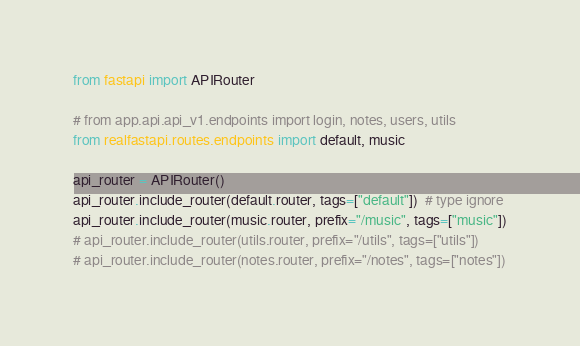<code> <loc_0><loc_0><loc_500><loc_500><_Python_>from fastapi import APIRouter

# from app.api.api_v1.endpoints import login, notes, users, utils
from realfastapi.routes.endpoints import default, music

api_router = APIRouter()
api_router.include_router(default.router, tags=["default"])  # type ignore
api_router.include_router(music.router, prefix="/music", tags=["music"])
# api_router.include_router(utils.router, prefix="/utils", tags=["utils"])
# api_router.include_router(notes.router, prefix="/notes", tags=["notes"])
</code> 